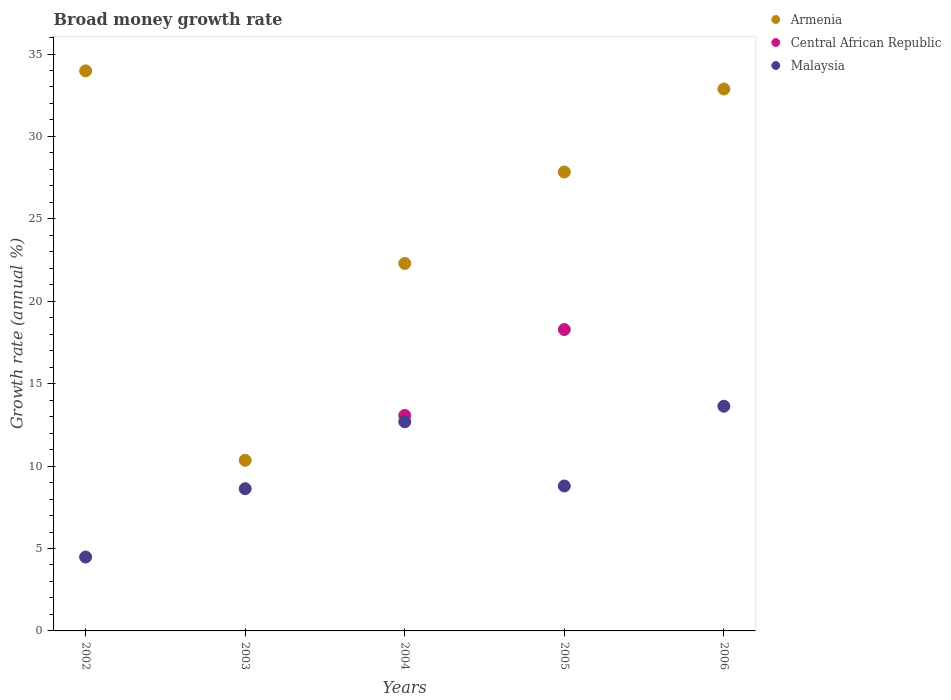Is the number of dotlines equal to the number of legend labels?
Give a very brief answer. No. What is the growth rate in Malaysia in 2004?
Offer a terse response. 12.69. Across all years, what is the maximum growth rate in Central African Republic?
Give a very brief answer. 18.28. Across all years, what is the minimum growth rate in Central African Republic?
Give a very brief answer. 0. What is the total growth rate in Malaysia in the graph?
Offer a terse response. 48.22. What is the difference between the growth rate in Malaysia in 2003 and that in 2006?
Give a very brief answer. -5. What is the difference between the growth rate in Armenia in 2004 and the growth rate in Malaysia in 2003?
Provide a short and direct response. 13.67. What is the average growth rate in Malaysia per year?
Provide a succinct answer. 9.64. In the year 2003, what is the difference between the growth rate in Armenia and growth rate in Malaysia?
Ensure brevity in your answer.  1.72. In how many years, is the growth rate in Malaysia greater than 35 %?
Give a very brief answer. 0. What is the ratio of the growth rate in Malaysia in 2003 to that in 2004?
Ensure brevity in your answer.  0.68. Is the growth rate in Armenia in 2002 less than that in 2006?
Make the answer very short. No. Is the difference between the growth rate in Armenia in 2003 and 2006 greater than the difference between the growth rate in Malaysia in 2003 and 2006?
Your answer should be very brief. No. What is the difference between the highest and the second highest growth rate in Armenia?
Your answer should be very brief. 1.1. What is the difference between the highest and the lowest growth rate in Armenia?
Provide a succinct answer. 23.63. In how many years, is the growth rate in Central African Republic greater than the average growth rate in Central African Republic taken over all years?
Provide a short and direct response. 2. Is the growth rate in Malaysia strictly greater than the growth rate in Armenia over the years?
Your response must be concise. No. How many years are there in the graph?
Keep it short and to the point. 5. Are the values on the major ticks of Y-axis written in scientific E-notation?
Offer a very short reply. No. Does the graph contain any zero values?
Give a very brief answer. Yes. Does the graph contain grids?
Offer a terse response. No. How many legend labels are there?
Keep it short and to the point. 3. How are the legend labels stacked?
Offer a very short reply. Vertical. What is the title of the graph?
Make the answer very short. Broad money growth rate. What is the label or title of the Y-axis?
Your answer should be compact. Growth rate (annual %). What is the Growth rate (annual %) of Armenia in 2002?
Ensure brevity in your answer.  33.98. What is the Growth rate (annual %) of Central African Republic in 2002?
Your response must be concise. 0. What is the Growth rate (annual %) of Malaysia in 2002?
Keep it short and to the point. 4.48. What is the Growth rate (annual %) in Armenia in 2003?
Ensure brevity in your answer.  10.35. What is the Growth rate (annual %) in Central African Republic in 2003?
Provide a short and direct response. 0. What is the Growth rate (annual %) in Malaysia in 2003?
Your answer should be very brief. 8.63. What is the Growth rate (annual %) of Armenia in 2004?
Your response must be concise. 22.29. What is the Growth rate (annual %) in Central African Republic in 2004?
Provide a short and direct response. 13.07. What is the Growth rate (annual %) in Malaysia in 2004?
Make the answer very short. 12.69. What is the Growth rate (annual %) of Armenia in 2005?
Give a very brief answer. 27.84. What is the Growth rate (annual %) of Central African Republic in 2005?
Your answer should be very brief. 18.28. What is the Growth rate (annual %) of Malaysia in 2005?
Keep it short and to the point. 8.79. What is the Growth rate (annual %) in Armenia in 2006?
Keep it short and to the point. 32.88. What is the Growth rate (annual %) in Malaysia in 2006?
Provide a short and direct response. 13.63. Across all years, what is the maximum Growth rate (annual %) in Armenia?
Give a very brief answer. 33.98. Across all years, what is the maximum Growth rate (annual %) of Central African Republic?
Give a very brief answer. 18.28. Across all years, what is the maximum Growth rate (annual %) in Malaysia?
Provide a short and direct response. 13.63. Across all years, what is the minimum Growth rate (annual %) in Armenia?
Ensure brevity in your answer.  10.35. Across all years, what is the minimum Growth rate (annual %) in Malaysia?
Give a very brief answer. 4.48. What is the total Growth rate (annual %) in Armenia in the graph?
Provide a short and direct response. 127.34. What is the total Growth rate (annual %) of Central African Republic in the graph?
Give a very brief answer. 31.36. What is the total Growth rate (annual %) in Malaysia in the graph?
Give a very brief answer. 48.22. What is the difference between the Growth rate (annual %) in Armenia in 2002 and that in 2003?
Provide a succinct answer. 23.63. What is the difference between the Growth rate (annual %) in Malaysia in 2002 and that in 2003?
Your response must be concise. -4.14. What is the difference between the Growth rate (annual %) of Armenia in 2002 and that in 2004?
Keep it short and to the point. 11.68. What is the difference between the Growth rate (annual %) of Malaysia in 2002 and that in 2004?
Ensure brevity in your answer.  -8.2. What is the difference between the Growth rate (annual %) in Armenia in 2002 and that in 2005?
Make the answer very short. 6.14. What is the difference between the Growth rate (annual %) in Malaysia in 2002 and that in 2005?
Provide a succinct answer. -4.31. What is the difference between the Growth rate (annual %) of Armenia in 2002 and that in 2006?
Offer a very short reply. 1.1. What is the difference between the Growth rate (annual %) in Malaysia in 2002 and that in 2006?
Your response must be concise. -9.15. What is the difference between the Growth rate (annual %) of Armenia in 2003 and that in 2004?
Your response must be concise. -11.94. What is the difference between the Growth rate (annual %) in Malaysia in 2003 and that in 2004?
Provide a short and direct response. -4.06. What is the difference between the Growth rate (annual %) of Armenia in 2003 and that in 2005?
Offer a very short reply. -17.49. What is the difference between the Growth rate (annual %) of Malaysia in 2003 and that in 2005?
Your answer should be compact. -0.17. What is the difference between the Growth rate (annual %) of Armenia in 2003 and that in 2006?
Make the answer very short. -22.53. What is the difference between the Growth rate (annual %) in Malaysia in 2003 and that in 2006?
Your answer should be very brief. -5. What is the difference between the Growth rate (annual %) of Armenia in 2004 and that in 2005?
Give a very brief answer. -5.55. What is the difference between the Growth rate (annual %) in Central African Republic in 2004 and that in 2005?
Provide a short and direct response. -5.21. What is the difference between the Growth rate (annual %) in Malaysia in 2004 and that in 2005?
Your answer should be very brief. 3.89. What is the difference between the Growth rate (annual %) in Armenia in 2004 and that in 2006?
Offer a very short reply. -10.58. What is the difference between the Growth rate (annual %) in Malaysia in 2004 and that in 2006?
Your answer should be compact. -0.94. What is the difference between the Growth rate (annual %) of Armenia in 2005 and that in 2006?
Your answer should be compact. -5.04. What is the difference between the Growth rate (annual %) of Malaysia in 2005 and that in 2006?
Your answer should be very brief. -4.84. What is the difference between the Growth rate (annual %) of Armenia in 2002 and the Growth rate (annual %) of Malaysia in 2003?
Your answer should be compact. 25.35. What is the difference between the Growth rate (annual %) of Armenia in 2002 and the Growth rate (annual %) of Central African Republic in 2004?
Ensure brevity in your answer.  20.9. What is the difference between the Growth rate (annual %) of Armenia in 2002 and the Growth rate (annual %) of Malaysia in 2004?
Keep it short and to the point. 21.29. What is the difference between the Growth rate (annual %) of Armenia in 2002 and the Growth rate (annual %) of Central African Republic in 2005?
Give a very brief answer. 15.69. What is the difference between the Growth rate (annual %) of Armenia in 2002 and the Growth rate (annual %) of Malaysia in 2005?
Make the answer very short. 25.18. What is the difference between the Growth rate (annual %) in Armenia in 2002 and the Growth rate (annual %) in Malaysia in 2006?
Keep it short and to the point. 20.35. What is the difference between the Growth rate (annual %) in Armenia in 2003 and the Growth rate (annual %) in Central African Republic in 2004?
Offer a very short reply. -2.72. What is the difference between the Growth rate (annual %) of Armenia in 2003 and the Growth rate (annual %) of Malaysia in 2004?
Provide a succinct answer. -2.34. What is the difference between the Growth rate (annual %) in Armenia in 2003 and the Growth rate (annual %) in Central African Republic in 2005?
Your answer should be compact. -7.93. What is the difference between the Growth rate (annual %) in Armenia in 2003 and the Growth rate (annual %) in Malaysia in 2005?
Your answer should be very brief. 1.56. What is the difference between the Growth rate (annual %) in Armenia in 2003 and the Growth rate (annual %) in Malaysia in 2006?
Your answer should be compact. -3.28. What is the difference between the Growth rate (annual %) of Armenia in 2004 and the Growth rate (annual %) of Central African Republic in 2005?
Keep it short and to the point. 4.01. What is the difference between the Growth rate (annual %) in Central African Republic in 2004 and the Growth rate (annual %) in Malaysia in 2005?
Offer a very short reply. 4.28. What is the difference between the Growth rate (annual %) in Armenia in 2004 and the Growth rate (annual %) in Malaysia in 2006?
Your response must be concise. 8.66. What is the difference between the Growth rate (annual %) of Central African Republic in 2004 and the Growth rate (annual %) of Malaysia in 2006?
Keep it short and to the point. -0.56. What is the difference between the Growth rate (annual %) of Armenia in 2005 and the Growth rate (annual %) of Malaysia in 2006?
Your response must be concise. 14.21. What is the difference between the Growth rate (annual %) of Central African Republic in 2005 and the Growth rate (annual %) of Malaysia in 2006?
Provide a short and direct response. 4.65. What is the average Growth rate (annual %) in Armenia per year?
Provide a succinct answer. 25.47. What is the average Growth rate (annual %) in Central African Republic per year?
Your answer should be compact. 6.27. What is the average Growth rate (annual %) in Malaysia per year?
Keep it short and to the point. 9.64. In the year 2002, what is the difference between the Growth rate (annual %) in Armenia and Growth rate (annual %) in Malaysia?
Provide a short and direct response. 29.49. In the year 2003, what is the difference between the Growth rate (annual %) of Armenia and Growth rate (annual %) of Malaysia?
Provide a succinct answer. 1.72. In the year 2004, what is the difference between the Growth rate (annual %) in Armenia and Growth rate (annual %) in Central African Republic?
Keep it short and to the point. 9.22. In the year 2004, what is the difference between the Growth rate (annual %) of Armenia and Growth rate (annual %) of Malaysia?
Make the answer very short. 9.61. In the year 2004, what is the difference between the Growth rate (annual %) in Central African Republic and Growth rate (annual %) in Malaysia?
Give a very brief answer. 0.39. In the year 2005, what is the difference between the Growth rate (annual %) of Armenia and Growth rate (annual %) of Central African Republic?
Give a very brief answer. 9.56. In the year 2005, what is the difference between the Growth rate (annual %) of Armenia and Growth rate (annual %) of Malaysia?
Provide a succinct answer. 19.05. In the year 2005, what is the difference between the Growth rate (annual %) in Central African Republic and Growth rate (annual %) in Malaysia?
Your answer should be very brief. 9.49. In the year 2006, what is the difference between the Growth rate (annual %) in Armenia and Growth rate (annual %) in Malaysia?
Give a very brief answer. 19.25. What is the ratio of the Growth rate (annual %) of Armenia in 2002 to that in 2003?
Provide a short and direct response. 3.28. What is the ratio of the Growth rate (annual %) in Malaysia in 2002 to that in 2003?
Make the answer very short. 0.52. What is the ratio of the Growth rate (annual %) in Armenia in 2002 to that in 2004?
Ensure brevity in your answer.  1.52. What is the ratio of the Growth rate (annual %) in Malaysia in 2002 to that in 2004?
Offer a very short reply. 0.35. What is the ratio of the Growth rate (annual %) of Armenia in 2002 to that in 2005?
Ensure brevity in your answer.  1.22. What is the ratio of the Growth rate (annual %) of Malaysia in 2002 to that in 2005?
Make the answer very short. 0.51. What is the ratio of the Growth rate (annual %) of Armenia in 2002 to that in 2006?
Your answer should be compact. 1.03. What is the ratio of the Growth rate (annual %) of Malaysia in 2002 to that in 2006?
Make the answer very short. 0.33. What is the ratio of the Growth rate (annual %) in Armenia in 2003 to that in 2004?
Your answer should be compact. 0.46. What is the ratio of the Growth rate (annual %) in Malaysia in 2003 to that in 2004?
Provide a succinct answer. 0.68. What is the ratio of the Growth rate (annual %) of Armenia in 2003 to that in 2005?
Provide a succinct answer. 0.37. What is the ratio of the Growth rate (annual %) of Malaysia in 2003 to that in 2005?
Provide a short and direct response. 0.98. What is the ratio of the Growth rate (annual %) of Armenia in 2003 to that in 2006?
Keep it short and to the point. 0.31. What is the ratio of the Growth rate (annual %) of Malaysia in 2003 to that in 2006?
Your answer should be compact. 0.63. What is the ratio of the Growth rate (annual %) in Armenia in 2004 to that in 2005?
Offer a very short reply. 0.8. What is the ratio of the Growth rate (annual %) in Central African Republic in 2004 to that in 2005?
Give a very brief answer. 0.72. What is the ratio of the Growth rate (annual %) of Malaysia in 2004 to that in 2005?
Give a very brief answer. 1.44. What is the ratio of the Growth rate (annual %) in Armenia in 2004 to that in 2006?
Provide a short and direct response. 0.68. What is the ratio of the Growth rate (annual %) of Malaysia in 2004 to that in 2006?
Provide a succinct answer. 0.93. What is the ratio of the Growth rate (annual %) in Armenia in 2005 to that in 2006?
Your answer should be compact. 0.85. What is the ratio of the Growth rate (annual %) in Malaysia in 2005 to that in 2006?
Keep it short and to the point. 0.65. What is the difference between the highest and the second highest Growth rate (annual %) of Armenia?
Make the answer very short. 1.1. What is the difference between the highest and the second highest Growth rate (annual %) in Malaysia?
Provide a short and direct response. 0.94. What is the difference between the highest and the lowest Growth rate (annual %) of Armenia?
Provide a short and direct response. 23.63. What is the difference between the highest and the lowest Growth rate (annual %) in Central African Republic?
Offer a very short reply. 18.28. What is the difference between the highest and the lowest Growth rate (annual %) of Malaysia?
Your answer should be very brief. 9.15. 